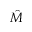Convert formula to latex. <formula><loc_0><loc_0><loc_500><loc_500>\hat { M }</formula> 